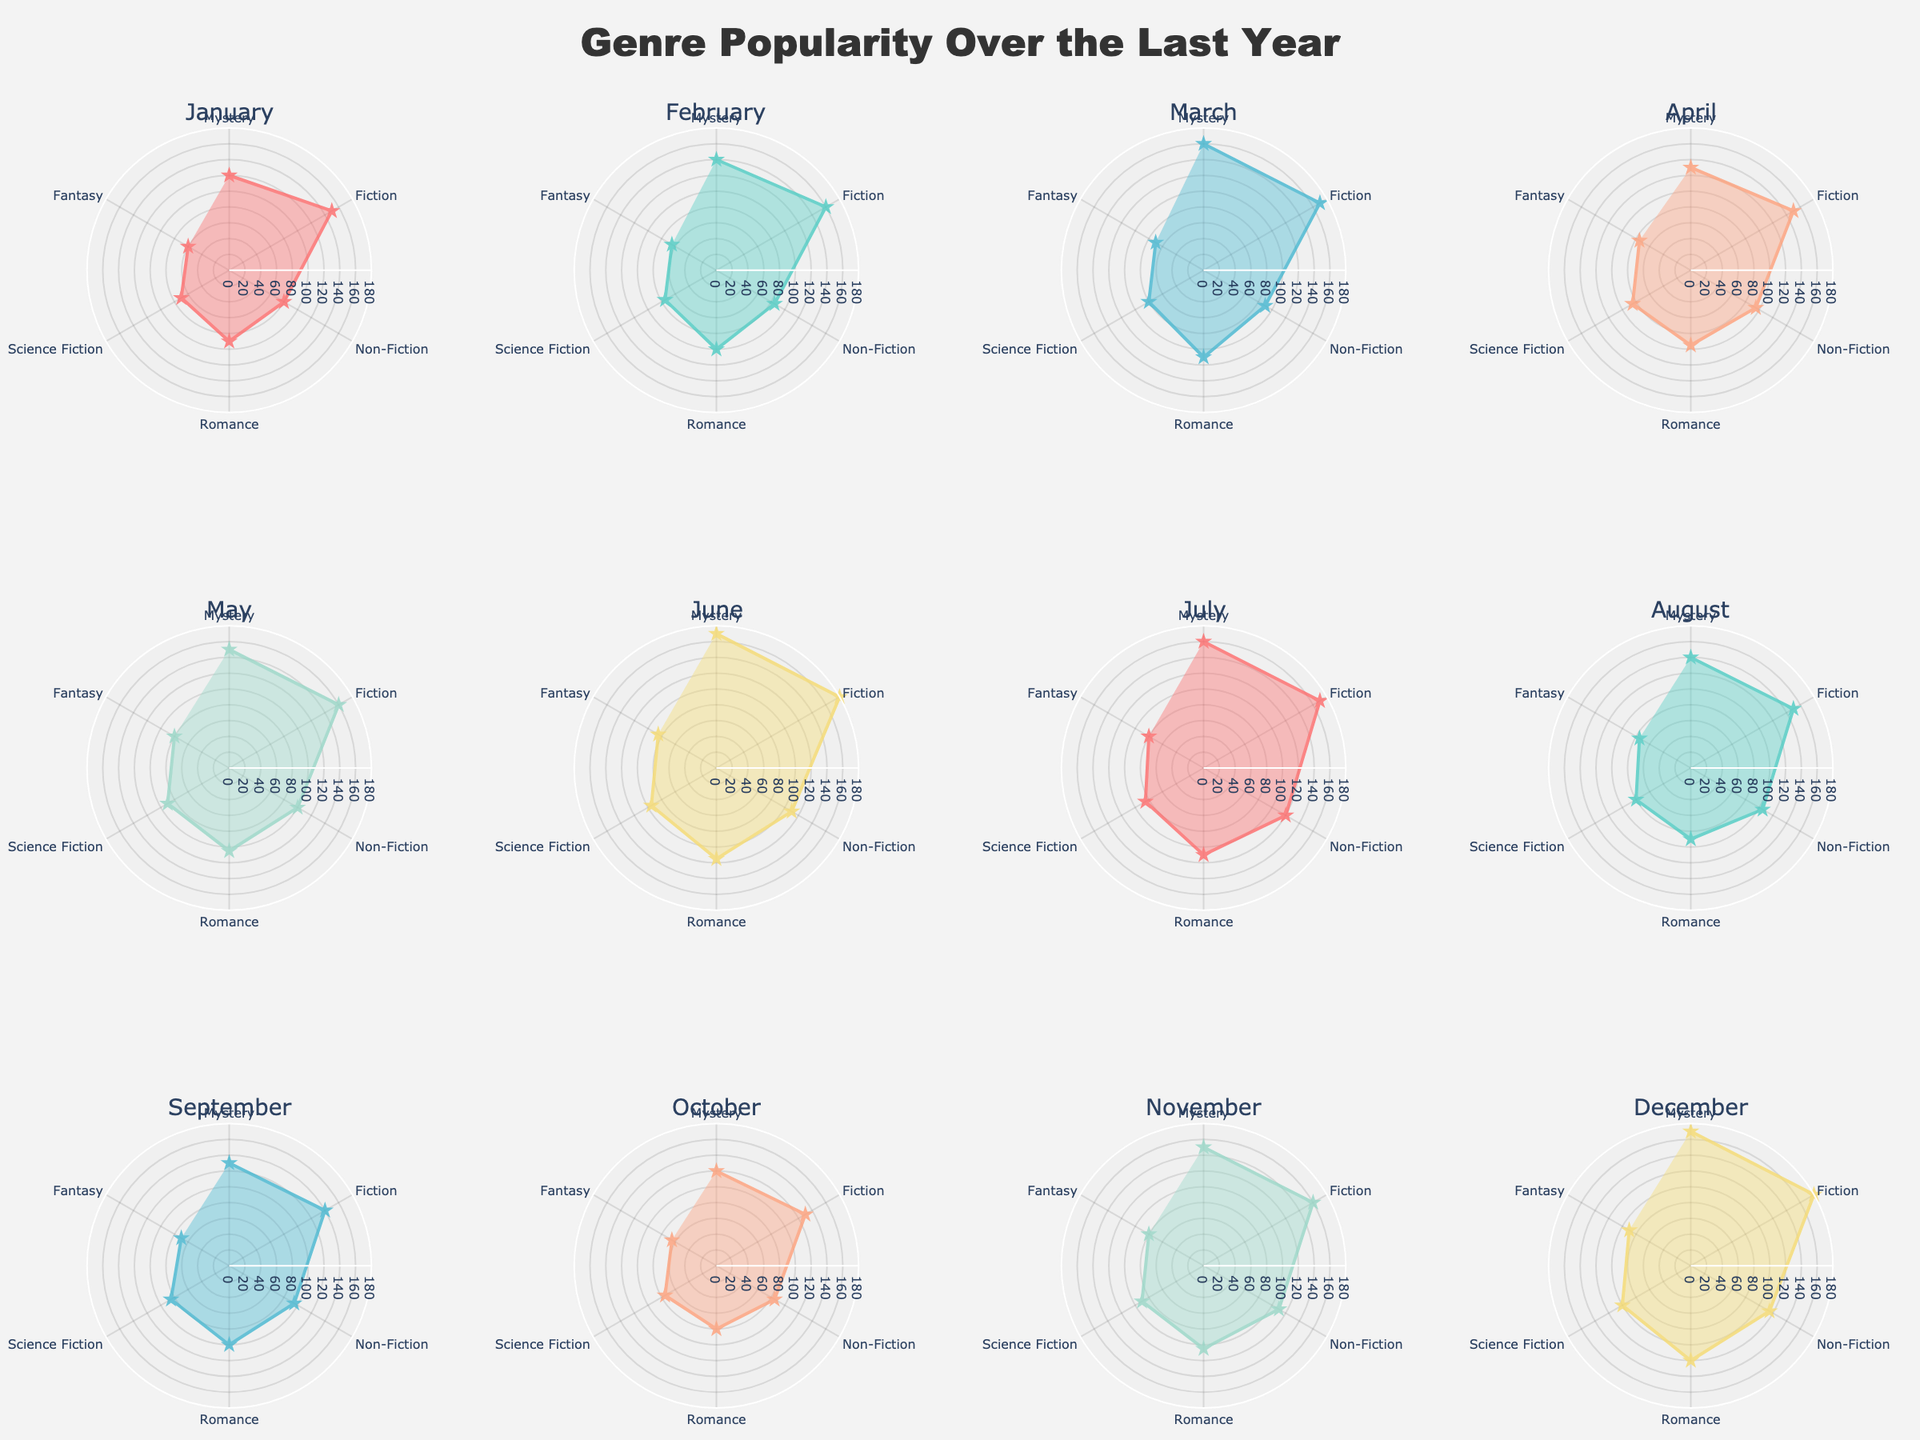What's the title of the figure? The title of the figure is usually prominent and located at the top center of the chart. It is a textual description of what the chart represents.
Answer: "Genre Popularity Over the Last Year" Which genre had the highest number of books rented in December? By examining the figure for the December subplot, you can see the radial distance for each genre. The genre with the longest radial distance has the highest number of books rented.
Answer: Fiction Which month had the lowest number of romance books rented? Look at the Romance segment for each month in the polar subplots. Compare the radial distances and identify the shortest one.
Answer: October In which month did Mystery and Science Fiction have the same number of books rented? Check each month's subplot and compare the radial distances for Mystery and Science Fiction. Find the month where their radial distances are equal.
Answer: September What is the average number of books rented for Non-Fiction across all months? Sum the number of Non-Fiction books rented for each month and divide by the number of months. The figures are 80, 85, 90, 95, 100, 110, 120, 105, 95, 85, 110, and 115. The total is 1180, and the average is 1180/12.
Answer: 98.33 Which month had the highest total number of books rented across all genres? Add the number of books rented for all genres in each month. Compare these totals to find the highest one. Summarizing monthly totals: January (570), February (625), March (680), April (630), May (685), June (755), July (725), August (640), September (615), October (555), November (695), December (775). December has the highest total.
Answer: December What is the overall trend for the number of Fantasy books rented throughout the year? Track the radial distances for the Fantasy genre in each month's subplot, observing how they increase, decrease, or remain stable as the months progress. The pattern shows fluctuations with some increase toward the end of the year.
Answer: Fluctuates with some increase How does the rental pattern for Fiction compare between March and June? Look at the Fiction segments in the subplots for March and June. Compare their radial distances and note any differences. March and June have high numbers, with June having a slightly larger radial distance.
Answer: Both high, but June is higher Which genres showed an increase in books rented from January to May? Compare the radial distances for each genre between January and May in the respective subplots. A genre showing a larger radial distance in May compared to January indicates an increase.
Answer: Mystery, Fiction, Non-Fiction, Romance, Science Fiction, Fantasy Is there any month where all genres have the same number of books rented? Examine each month's subplot and check if the radial distances for all genres are equal. This would indicate the same number of books rented for all genres.
Answer: No 